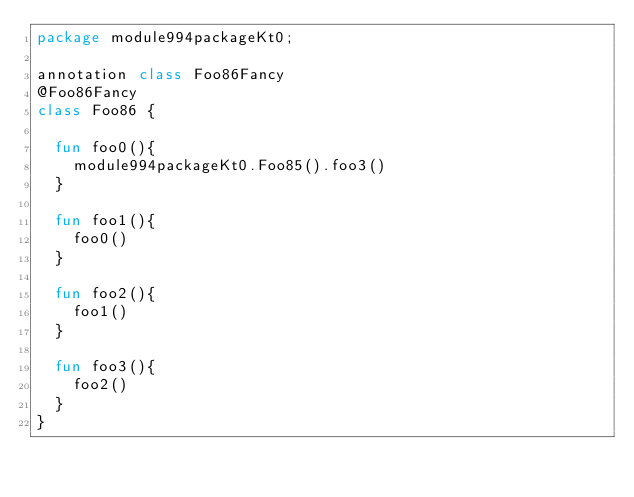Convert code to text. <code><loc_0><loc_0><loc_500><loc_500><_Kotlin_>package module994packageKt0;

annotation class Foo86Fancy
@Foo86Fancy
class Foo86 {

  fun foo0(){
    module994packageKt0.Foo85().foo3()
  }

  fun foo1(){
    foo0()
  }

  fun foo2(){
    foo1()
  }

  fun foo3(){
    foo2()
  }
}</code> 